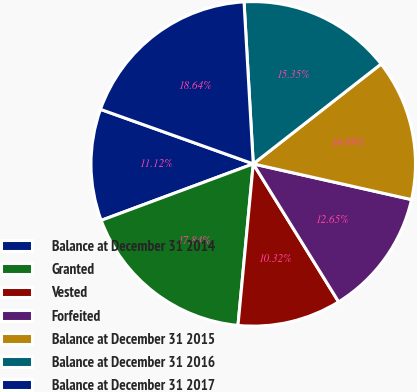Convert chart. <chart><loc_0><loc_0><loc_500><loc_500><pie_chart><fcel>Balance at December 31 2014<fcel>Granted<fcel>Vested<fcel>Forfeited<fcel>Balance at December 31 2015<fcel>Balance at December 31 2016<fcel>Balance at December 31 2017<nl><fcel>11.12%<fcel>17.84%<fcel>10.32%<fcel>12.65%<fcel>14.09%<fcel>15.35%<fcel>18.64%<nl></chart> 